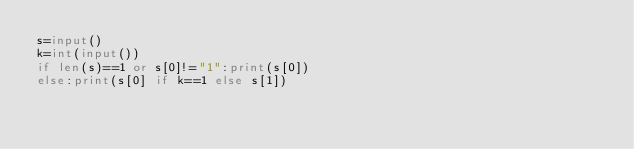Convert code to text. <code><loc_0><loc_0><loc_500><loc_500><_Python_>s=input()
k=int(input())
if len(s)==1 or s[0]!="1":print(s[0])
else:print(s[0] if k==1 else s[1])</code> 